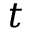Convert formula to latex. <formula><loc_0><loc_0><loc_500><loc_500>t</formula> 